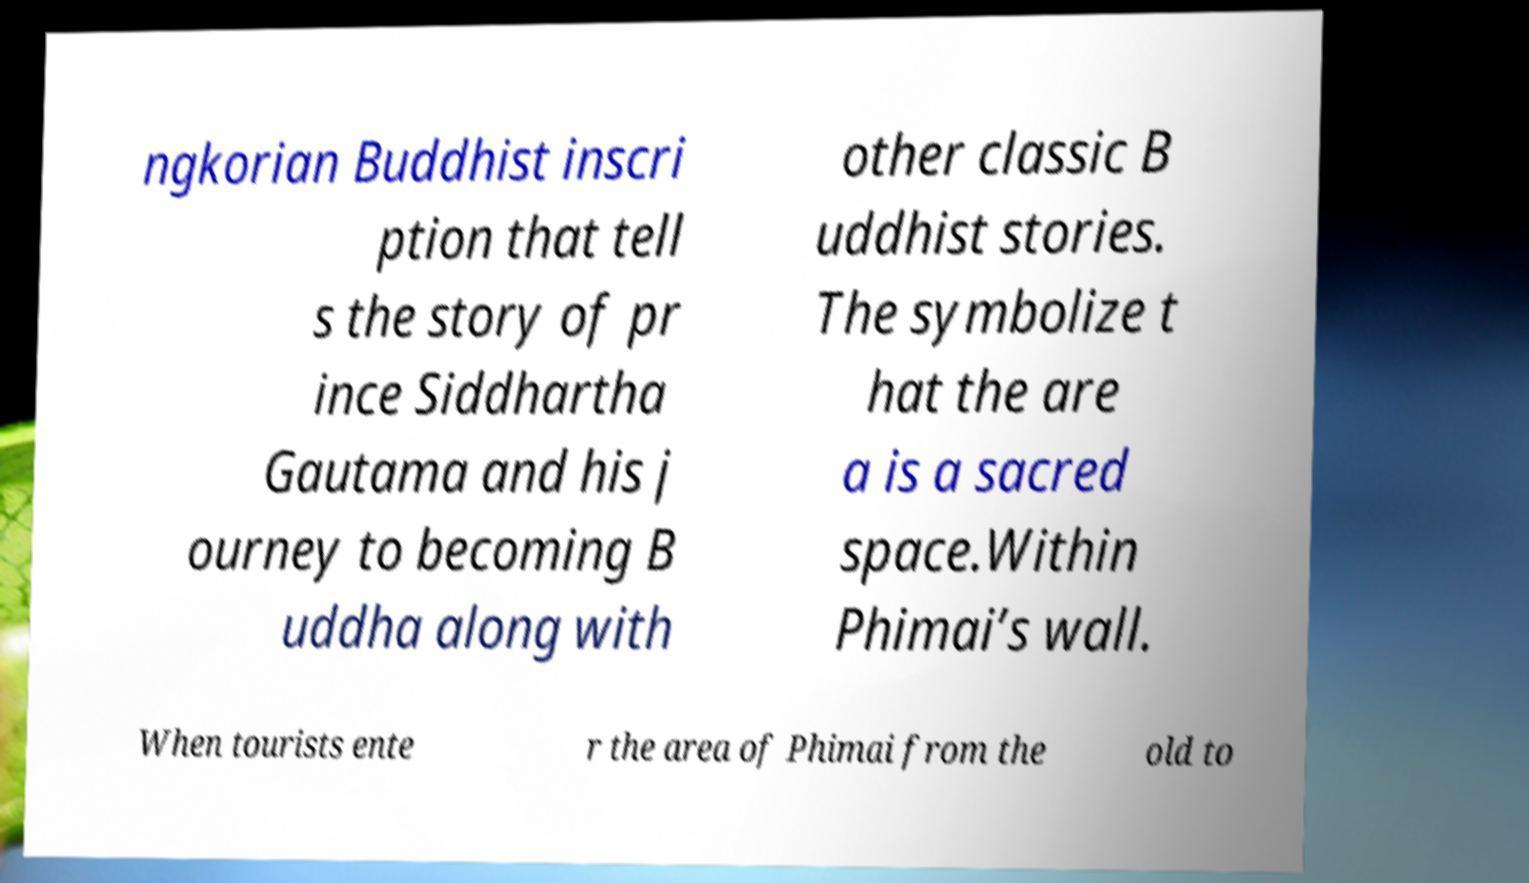Could you assist in decoding the text presented in this image and type it out clearly? ngkorian Buddhist inscri ption that tell s the story of pr ince Siddhartha Gautama and his j ourney to becoming B uddha along with other classic B uddhist stories. The symbolize t hat the are a is a sacred space.Within Phimai’s wall. When tourists ente r the area of Phimai from the old to 